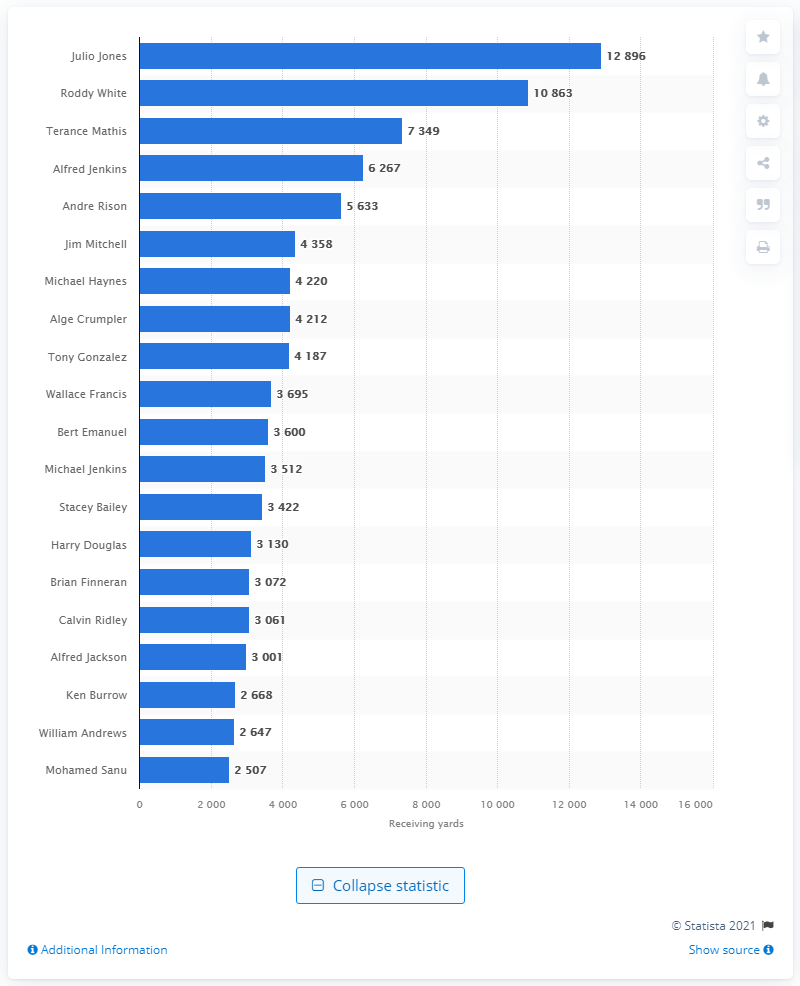Specify some key components in this picture. As of my knowledge cutoff date, Julio Jones is the career receiving leader of the Atlanta Falcons. 